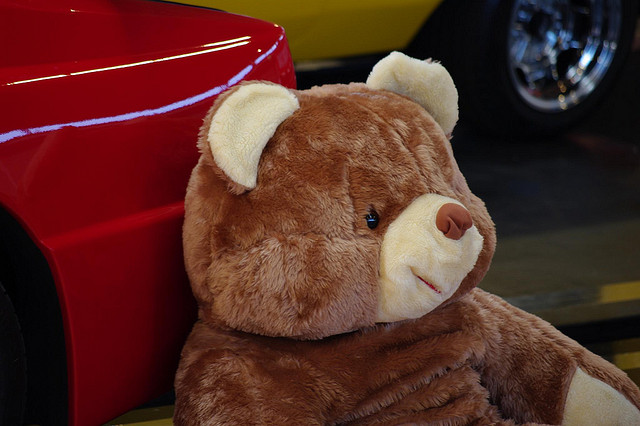<image>What color is the bow on the teddy bear? There is no bow on the teddy bear in the image. What color is the bow on the teddy bear? There is no bow on the teddy bear. 